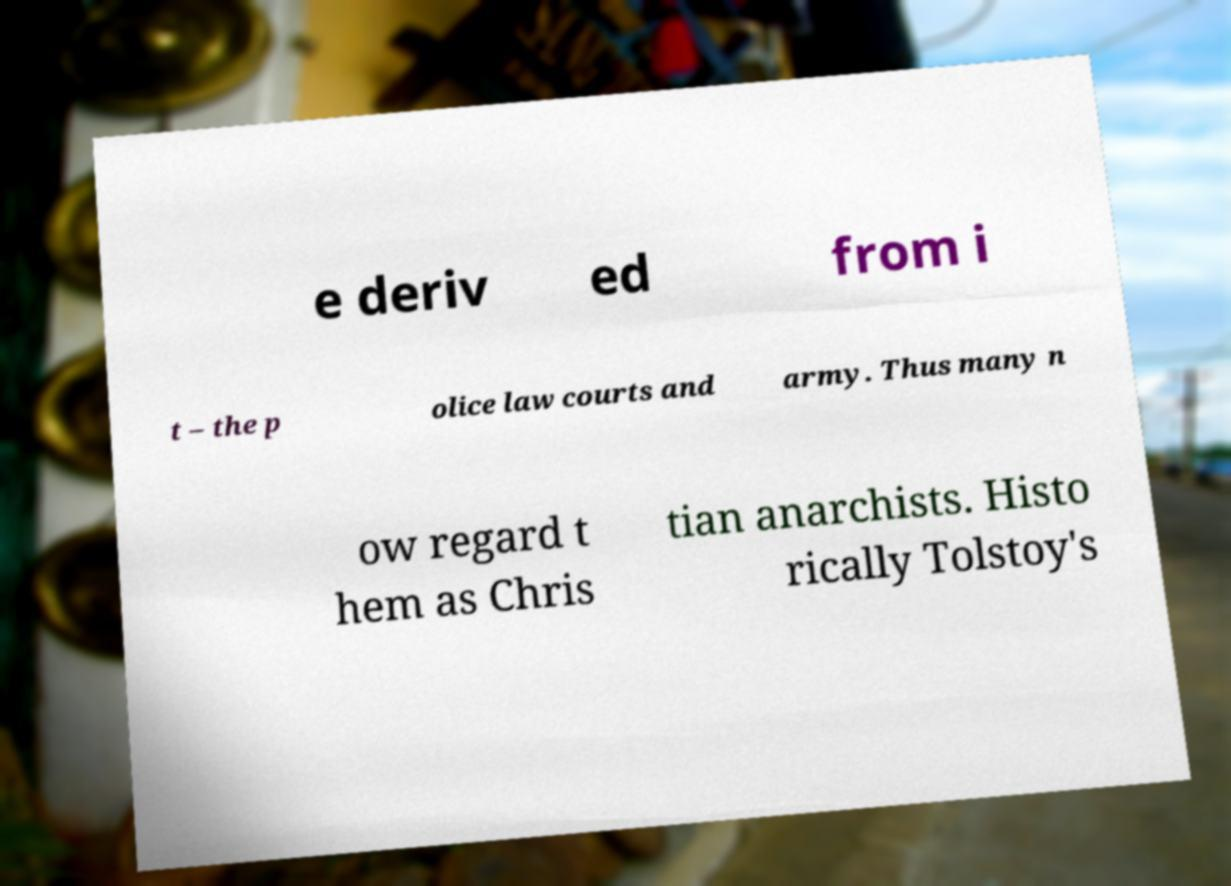I need the written content from this picture converted into text. Can you do that? e deriv ed from i t – the p olice law courts and army. Thus many n ow regard t hem as Chris tian anarchists. Histo rically Tolstoy's 